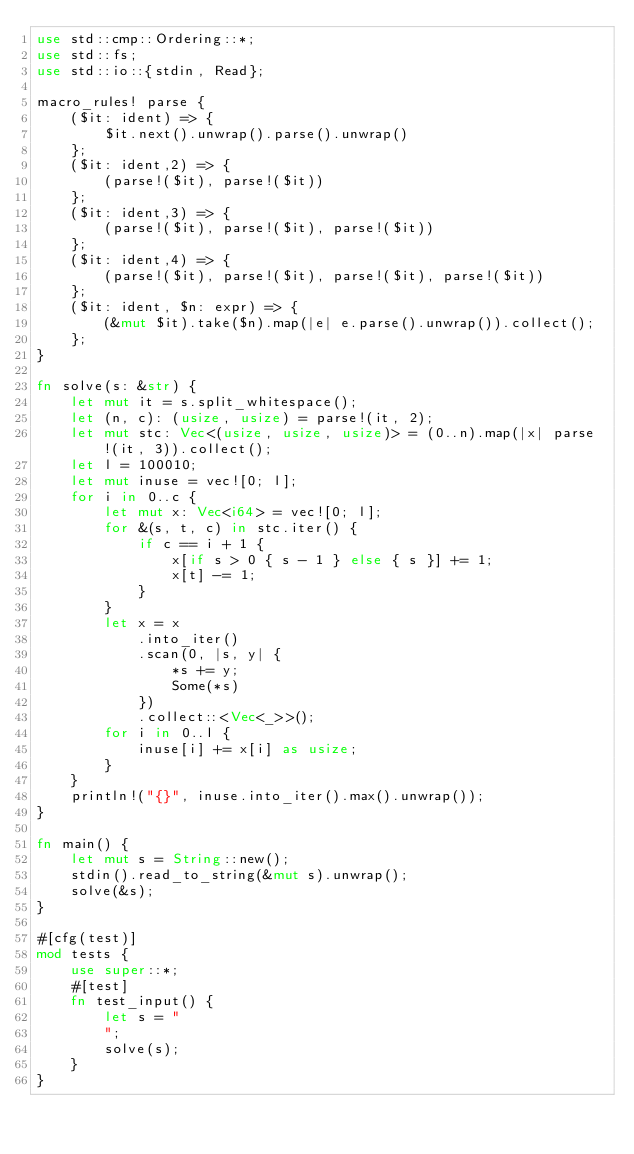Convert code to text. <code><loc_0><loc_0><loc_500><loc_500><_Rust_>use std::cmp::Ordering::*;
use std::fs;
use std::io::{stdin, Read};

macro_rules! parse {
    ($it: ident) => {
        $it.next().unwrap().parse().unwrap()
    };
    ($it: ident,2) => {
        (parse!($it), parse!($it))
    };
    ($it: ident,3) => {
        (parse!($it), parse!($it), parse!($it))
    };
    ($it: ident,4) => {
        (parse!($it), parse!($it), parse!($it), parse!($it))
    };
    ($it: ident, $n: expr) => {
        (&mut $it).take($n).map(|e| e.parse().unwrap()).collect();
    };
}

fn solve(s: &str) {
    let mut it = s.split_whitespace();
    let (n, c): (usize, usize) = parse!(it, 2);
    let mut stc: Vec<(usize, usize, usize)> = (0..n).map(|x| parse!(it, 3)).collect();
    let l = 100010;
    let mut inuse = vec![0; l];
    for i in 0..c {
        let mut x: Vec<i64> = vec![0; l];
        for &(s, t, c) in stc.iter() {
            if c == i + 1 {
                x[if s > 0 { s - 1 } else { s }] += 1;
                x[t] -= 1;
            }
        }
        let x = x
            .into_iter()
            .scan(0, |s, y| {
                *s += y;
                Some(*s)
            })
            .collect::<Vec<_>>();
        for i in 0..l {
            inuse[i] += x[i] as usize;
        }
    }
    println!("{}", inuse.into_iter().max().unwrap());
}

fn main() {
    let mut s = String::new();
    stdin().read_to_string(&mut s).unwrap();
    solve(&s);
}

#[cfg(test)]
mod tests {
    use super::*;
    #[test]
    fn test_input() {
        let s = "
        ";
        solve(s);
    }
}
</code> 